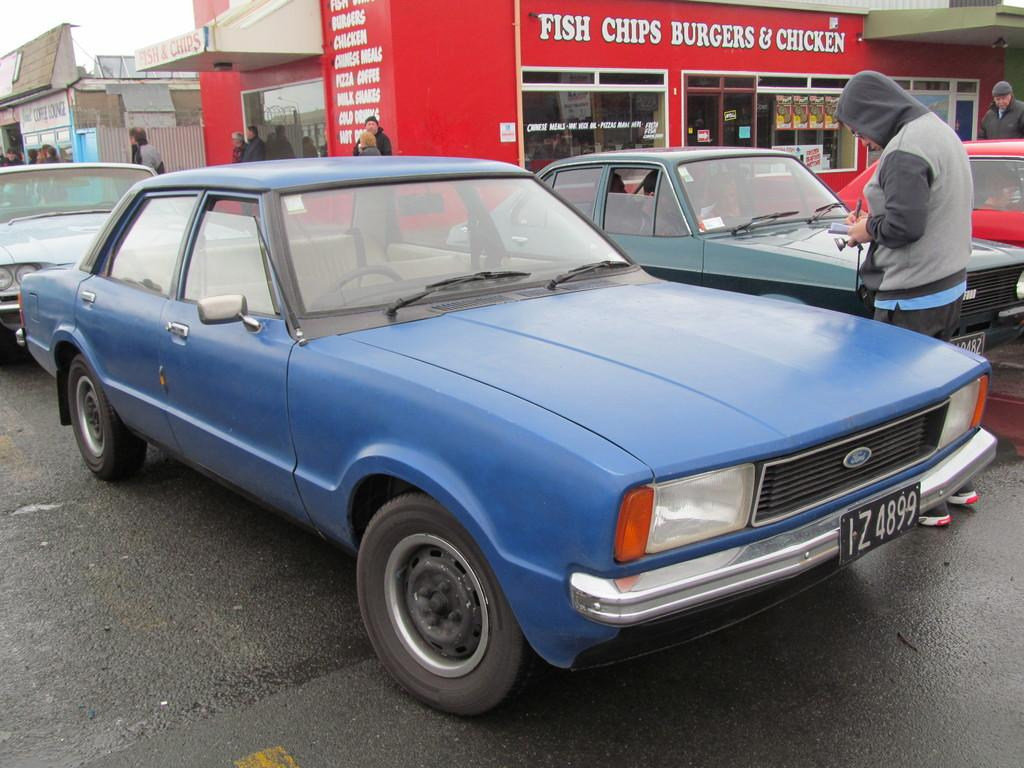<image>
Write a terse but informative summary of the picture. a red building with the word fish and chips on it 